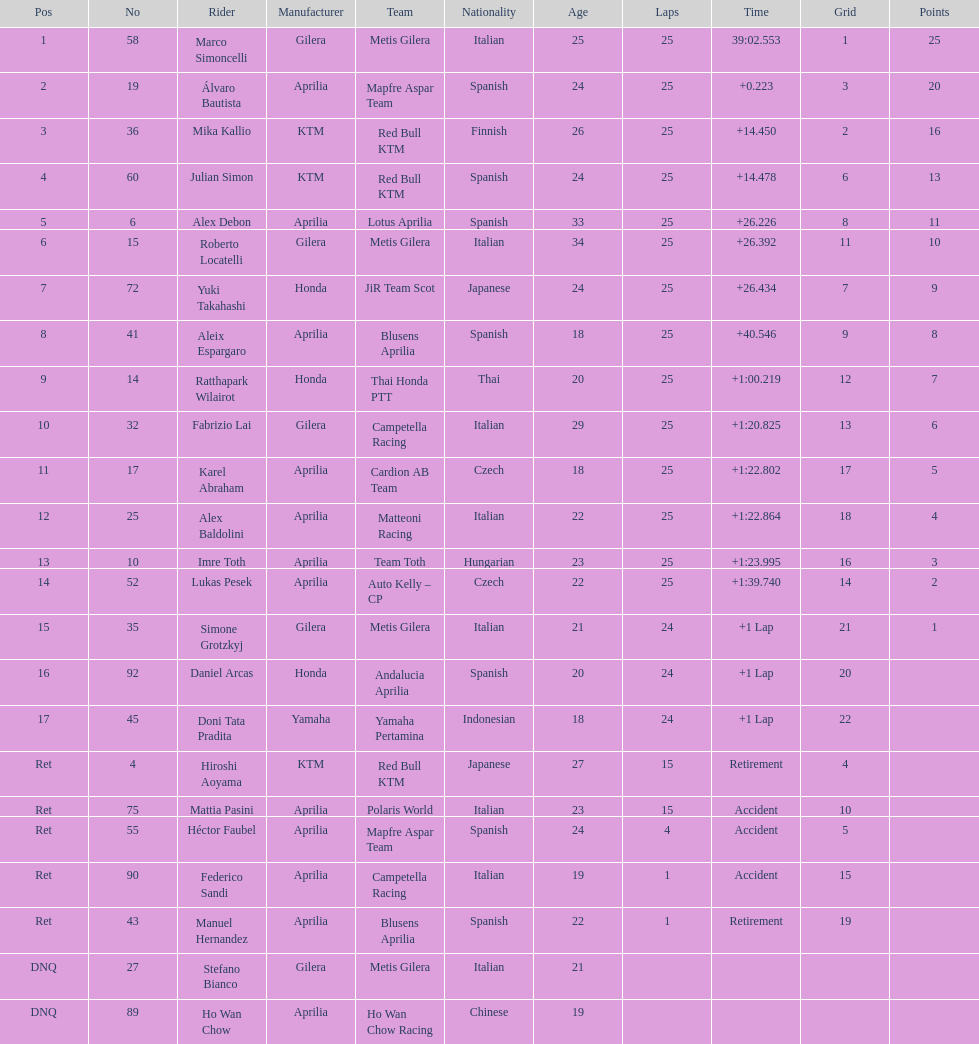Between marco simoncelli and hiroshi aoyama, who completed a greater number of laps? Marco Simoncelli. 